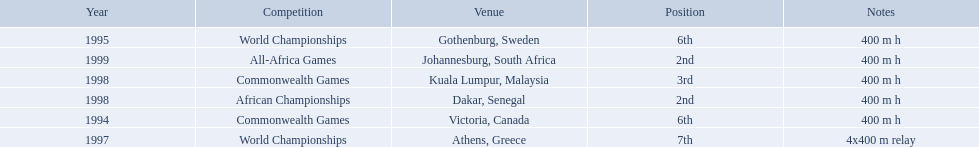What country was the 1997 championships held in? Athens, Greece. What long was the relay? 4x400 m relay. 